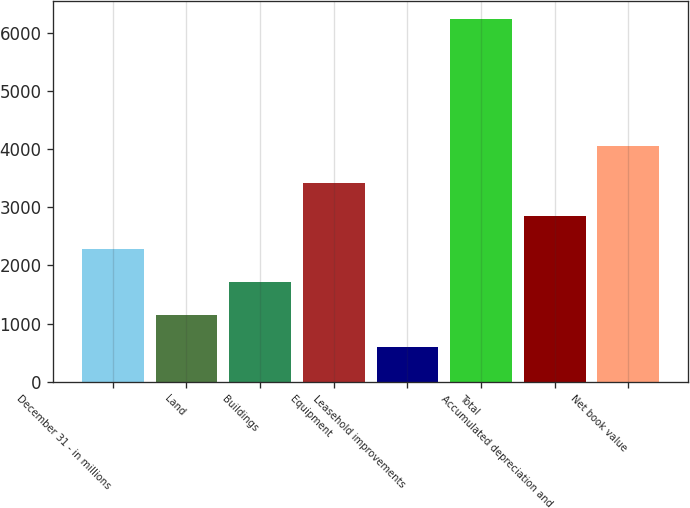Convert chart. <chart><loc_0><loc_0><loc_500><loc_500><bar_chart><fcel>December 31 - in millions<fcel>Land<fcel>Buildings<fcel>Equipment<fcel>Leasehold improvements<fcel>Total<fcel>Accumulated depreciation and<fcel>Net book value<nl><fcel>2284.4<fcel>1156.8<fcel>1720.6<fcel>3412<fcel>593<fcel>6231<fcel>2848.2<fcel>4059<nl></chart> 